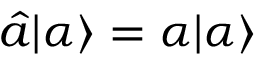Convert formula to latex. <formula><loc_0><loc_0><loc_500><loc_500>{ \hat { a } } | \alpha \rangle = \alpha | \alpha \rangle</formula> 